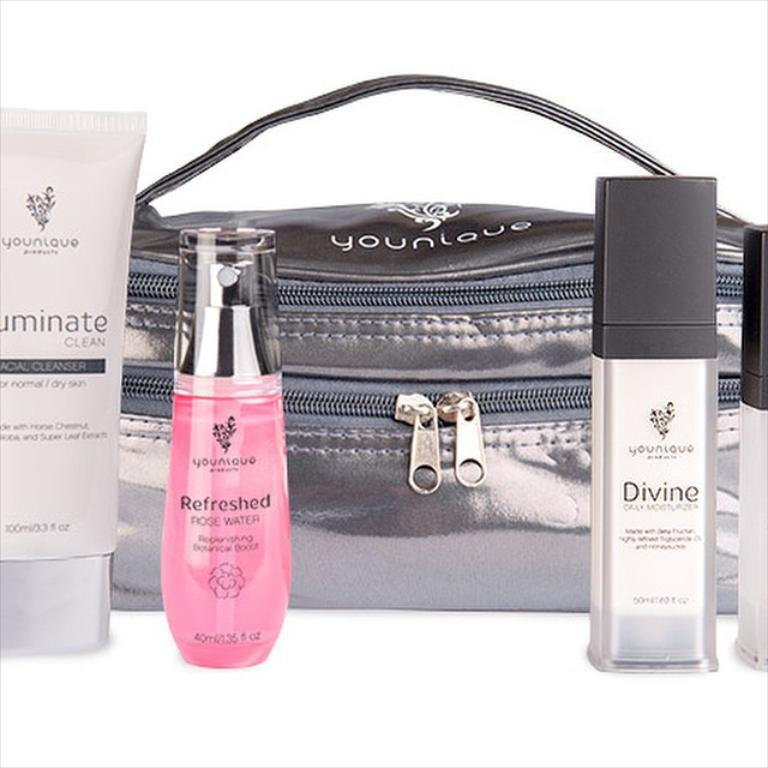Provide a one-sentence caption for the provided image. Personal care products displayed in front of a purse include small containers of Divine and Refreshed. 